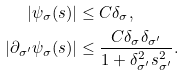<formula> <loc_0><loc_0><loc_500><loc_500>| \psi _ { \sigma } ( s ) | & \leq C \delta _ { \sigma } , \\ | \partial _ { \sigma ^ { \prime } } \psi _ { \sigma } ( s ) | & \leq \frac { C \delta _ { \sigma } \delta _ { \sigma ^ { \prime } } } { 1 + \delta _ { \sigma ^ { \prime } } ^ { 2 } s _ { \sigma ^ { \prime } } ^ { 2 } } .</formula> 